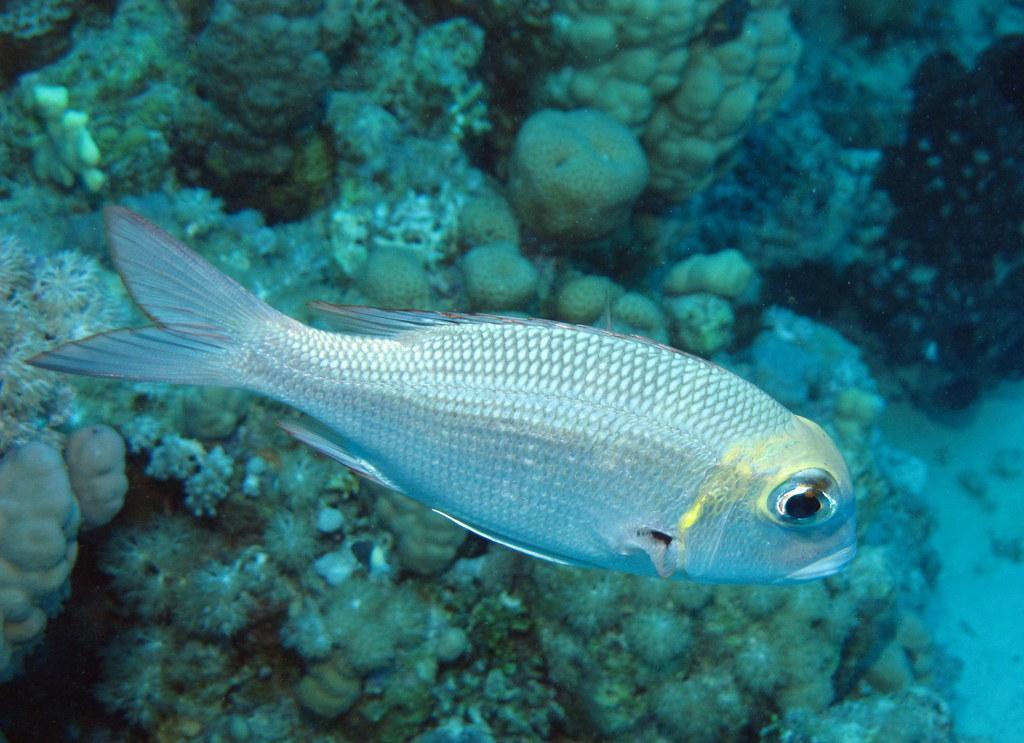Could you give a brief overview of what you see in this image? In this image we can see a fish, water, stones and other objects. 